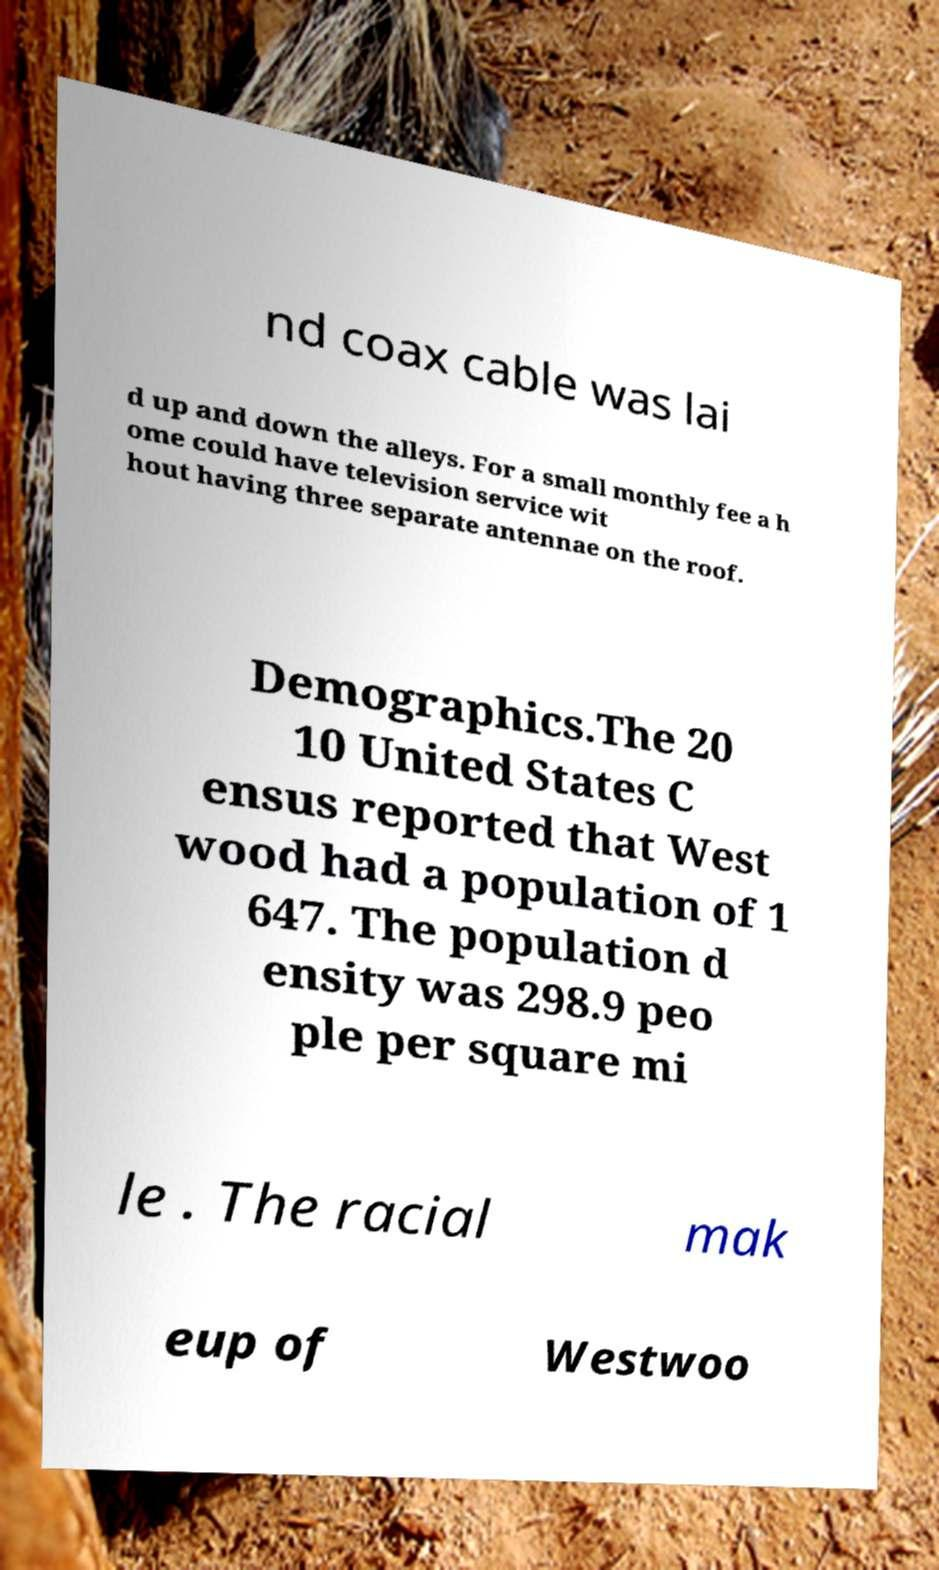Can you accurately transcribe the text from the provided image for me? nd coax cable was lai d up and down the alleys. For a small monthly fee a h ome could have television service wit hout having three separate antennae on the roof. Demographics.The 20 10 United States C ensus reported that West wood had a population of 1 647. The population d ensity was 298.9 peo ple per square mi le . The racial mak eup of Westwoo 